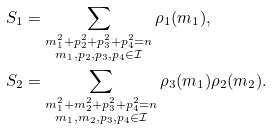Convert formula to latex. <formula><loc_0><loc_0><loc_500><loc_500>S _ { 1 } & = \sum _ { \substack { m _ { 1 } ^ { 2 } + p _ { 2 } ^ { 2 } + p _ { 3 } ^ { 2 } + p _ { 4 } ^ { 2 } = n \\ m _ { 1 } , p _ { 2 } , p _ { 3 } , p _ { 4 } \in \mathcal { I } } } \rho _ { 1 } ( m _ { 1 } ) , \\ S _ { 2 } & = \sum _ { \substack { m _ { 1 } ^ { 2 } + m _ { 2 } ^ { 2 } + p _ { 3 } ^ { 2 } + p _ { 4 } ^ { 2 } = n \\ m _ { 1 } , m _ { 2 } , p _ { 3 } , p _ { 4 } \in \mathcal { I } } } \rho _ { 3 } ( m _ { 1 } ) \rho _ { 2 } ( m _ { 2 } ) .</formula> 